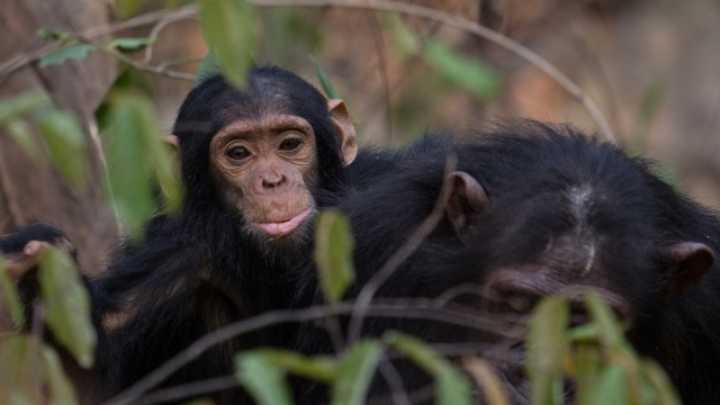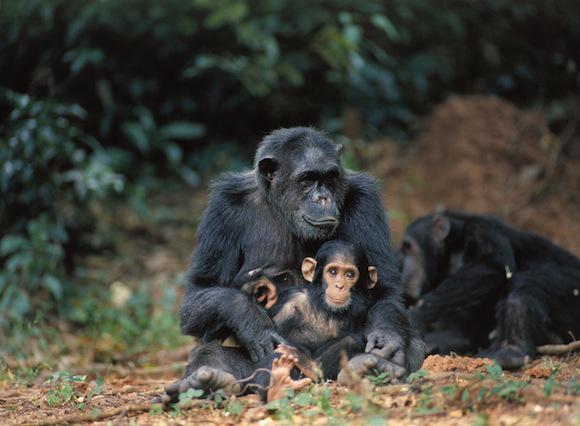The first image is the image on the left, the second image is the image on the right. For the images shown, is this caption "An image shows at least one adult chimp looking at a tiny body lying on the ground." true? Answer yes or no. No. The first image is the image on the left, the second image is the image on the right. Considering the images on both sides, is "One animal in the image on the right side is standing upright." valid? Answer yes or no. No. The first image is the image on the left, the second image is the image on the right. Considering the images on both sides, is "An image shows at least one chimp bent downward to look at a tiny body lying on the ground." valid? Answer yes or no. No. The first image is the image on the left, the second image is the image on the right. Examine the images to the left and right. Is the description "There is a total of four chimpanzees in the image pair." accurate? Answer yes or no. No. 